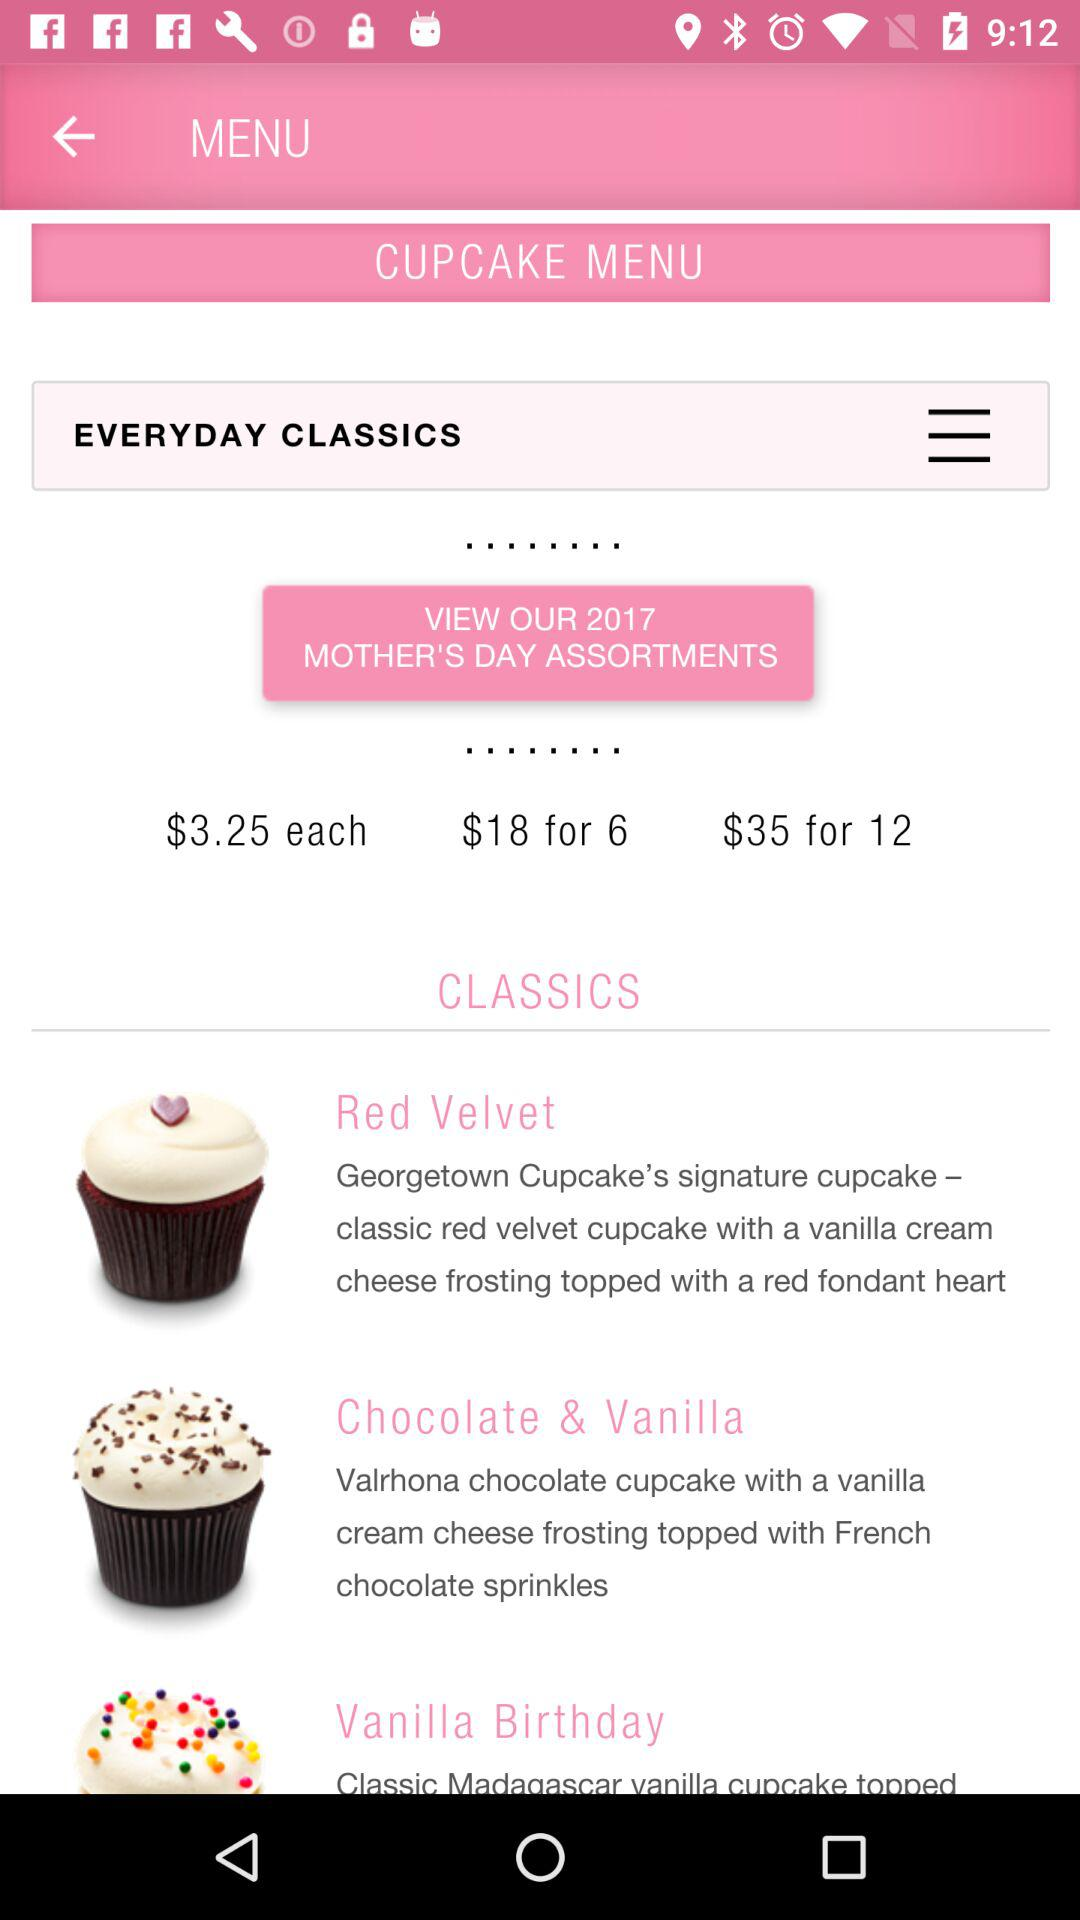What is the price of 12 cupcakes? The price of 12 cupcakes is $35. 